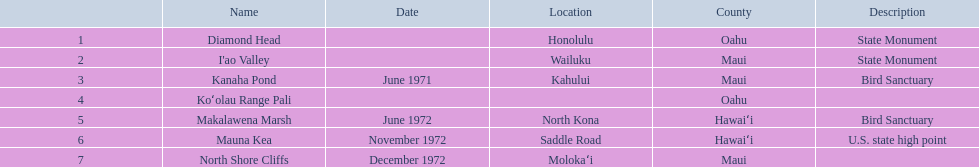What is the only name listed without a location? Koʻolau Range Pali. 